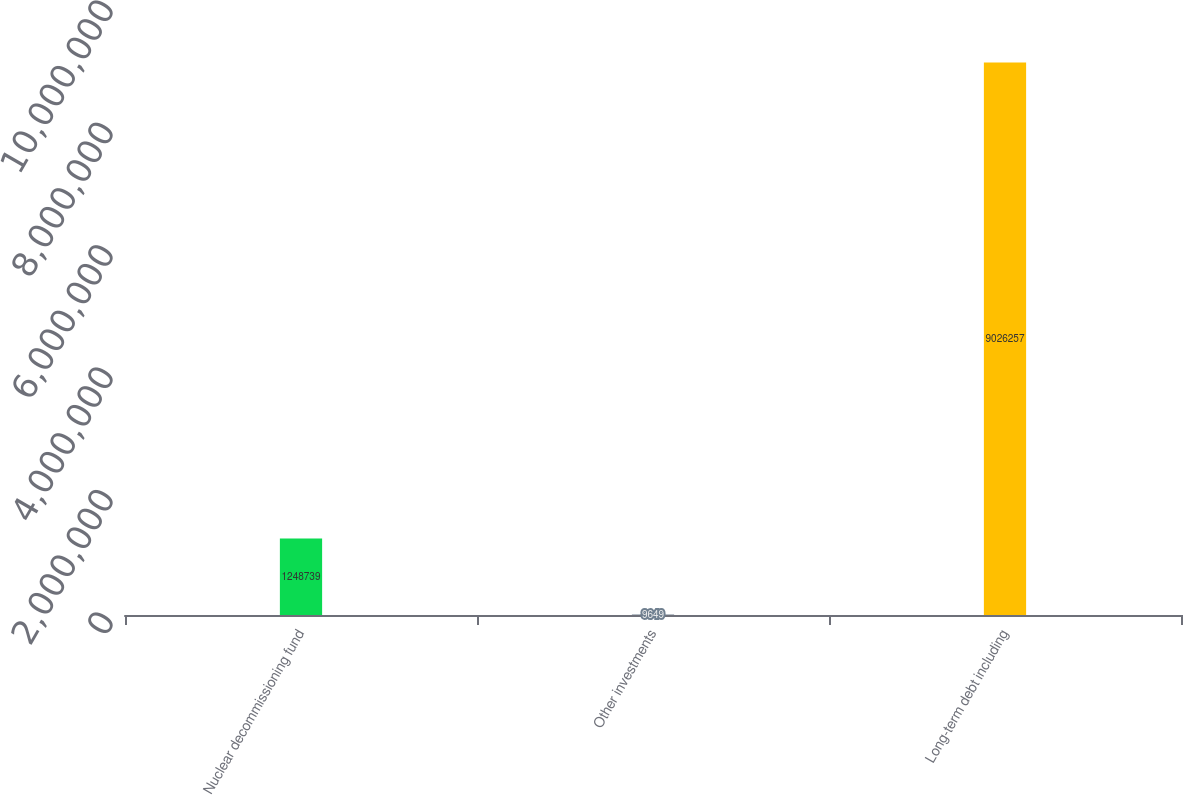Convert chart. <chart><loc_0><loc_0><loc_500><loc_500><bar_chart><fcel>Nuclear decommissioning fund<fcel>Other investments<fcel>Long-term debt including<nl><fcel>1.24874e+06<fcel>9649<fcel>9.02626e+06<nl></chart> 